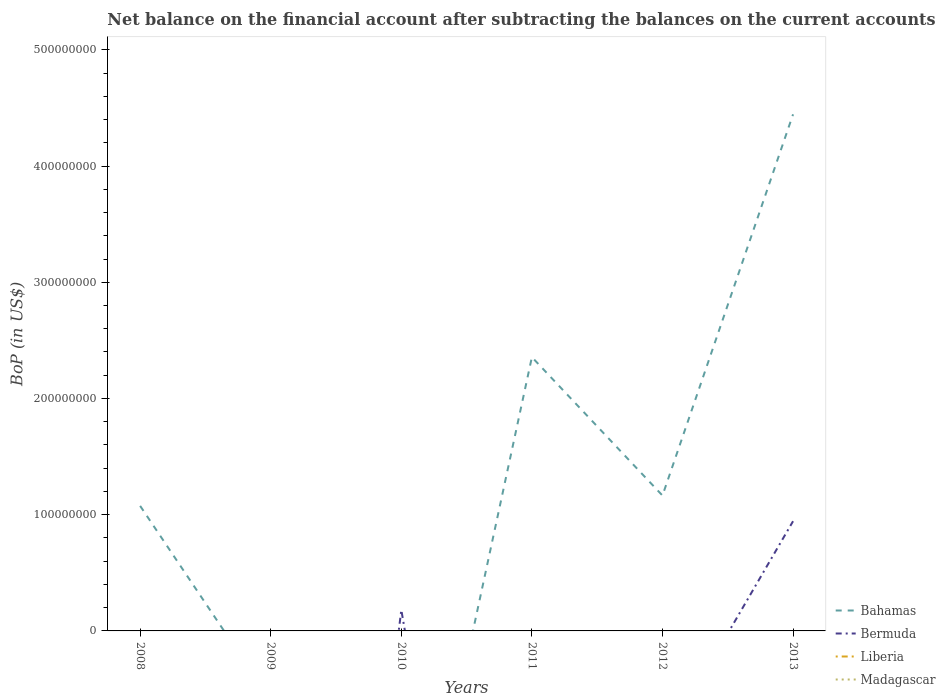Is the number of lines equal to the number of legend labels?
Make the answer very short. No. What is the total Balance of Payments in Bahamas in the graph?
Ensure brevity in your answer.  1.19e+08. What is the difference between the highest and the second highest Balance of Payments in Bahamas?
Keep it short and to the point. 4.44e+08. What is the difference between two consecutive major ticks on the Y-axis?
Provide a succinct answer. 1.00e+08. Are the values on the major ticks of Y-axis written in scientific E-notation?
Offer a terse response. No. Does the graph contain grids?
Keep it short and to the point. No. How many legend labels are there?
Offer a terse response. 4. What is the title of the graph?
Offer a terse response. Net balance on the financial account after subtracting the balances on the current accounts. Does "Belize" appear as one of the legend labels in the graph?
Make the answer very short. No. What is the label or title of the X-axis?
Offer a very short reply. Years. What is the label or title of the Y-axis?
Keep it short and to the point. BoP (in US$). What is the BoP (in US$) of Bahamas in 2008?
Offer a very short reply. 1.08e+08. What is the BoP (in US$) in Bermuda in 2008?
Your answer should be compact. 0. What is the BoP (in US$) of Liberia in 2008?
Make the answer very short. 0. What is the BoP (in US$) in Madagascar in 2008?
Provide a succinct answer. 0. What is the BoP (in US$) in Bahamas in 2009?
Provide a succinct answer. 0. What is the BoP (in US$) of Bermuda in 2009?
Offer a very short reply. 0. What is the BoP (in US$) in Liberia in 2009?
Your answer should be very brief. 0. What is the BoP (in US$) in Madagascar in 2009?
Ensure brevity in your answer.  0. What is the BoP (in US$) in Bermuda in 2010?
Keep it short and to the point. 1.80e+07. What is the BoP (in US$) of Liberia in 2010?
Give a very brief answer. 0. What is the BoP (in US$) of Madagascar in 2010?
Offer a terse response. 0. What is the BoP (in US$) of Bahamas in 2011?
Keep it short and to the point. 2.36e+08. What is the BoP (in US$) in Bermuda in 2011?
Provide a succinct answer. 0. What is the BoP (in US$) of Madagascar in 2011?
Provide a succinct answer. 0. What is the BoP (in US$) of Bahamas in 2012?
Your answer should be very brief. 1.16e+08. What is the BoP (in US$) in Bahamas in 2013?
Give a very brief answer. 4.44e+08. What is the BoP (in US$) in Bermuda in 2013?
Your answer should be compact. 9.44e+07. What is the BoP (in US$) of Liberia in 2013?
Ensure brevity in your answer.  0. Across all years, what is the maximum BoP (in US$) in Bahamas?
Ensure brevity in your answer.  4.44e+08. Across all years, what is the maximum BoP (in US$) of Bermuda?
Offer a very short reply. 9.44e+07. Across all years, what is the minimum BoP (in US$) of Bahamas?
Your response must be concise. 0. Across all years, what is the minimum BoP (in US$) of Bermuda?
Give a very brief answer. 0. What is the total BoP (in US$) of Bahamas in the graph?
Ensure brevity in your answer.  9.04e+08. What is the total BoP (in US$) in Bermuda in the graph?
Your answer should be compact. 1.12e+08. What is the total BoP (in US$) of Liberia in the graph?
Provide a succinct answer. 0. What is the total BoP (in US$) of Madagascar in the graph?
Give a very brief answer. 0. What is the difference between the BoP (in US$) of Bahamas in 2008 and that in 2011?
Give a very brief answer. -1.28e+08. What is the difference between the BoP (in US$) of Bahamas in 2008 and that in 2012?
Keep it short and to the point. -8.90e+06. What is the difference between the BoP (in US$) in Bahamas in 2008 and that in 2013?
Ensure brevity in your answer.  -3.37e+08. What is the difference between the BoP (in US$) in Bermuda in 2010 and that in 2013?
Your answer should be very brief. -7.64e+07. What is the difference between the BoP (in US$) of Bahamas in 2011 and that in 2012?
Your answer should be compact. 1.19e+08. What is the difference between the BoP (in US$) of Bahamas in 2011 and that in 2013?
Ensure brevity in your answer.  -2.09e+08. What is the difference between the BoP (in US$) of Bahamas in 2012 and that in 2013?
Ensure brevity in your answer.  -3.28e+08. What is the difference between the BoP (in US$) in Bahamas in 2008 and the BoP (in US$) in Bermuda in 2010?
Your response must be concise. 8.96e+07. What is the difference between the BoP (in US$) of Bahamas in 2008 and the BoP (in US$) of Bermuda in 2013?
Provide a succinct answer. 1.32e+07. What is the difference between the BoP (in US$) in Bahamas in 2011 and the BoP (in US$) in Bermuda in 2013?
Provide a short and direct response. 1.41e+08. What is the difference between the BoP (in US$) of Bahamas in 2012 and the BoP (in US$) of Bermuda in 2013?
Your answer should be very brief. 2.21e+07. What is the average BoP (in US$) in Bahamas per year?
Offer a terse response. 1.51e+08. What is the average BoP (in US$) of Bermuda per year?
Your response must be concise. 1.87e+07. In the year 2013, what is the difference between the BoP (in US$) in Bahamas and BoP (in US$) in Bermuda?
Make the answer very short. 3.50e+08. What is the ratio of the BoP (in US$) of Bahamas in 2008 to that in 2011?
Your response must be concise. 0.46. What is the ratio of the BoP (in US$) of Bahamas in 2008 to that in 2012?
Keep it short and to the point. 0.92. What is the ratio of the BoP (in US$) in Bahamas in 2008 to that in 2013?
Ensure brevity in your answer.  0.24. What is the ratio of the BoP (in US$) in Bermuda in 2010 to that in 2013?
Your answer should be very brief. 0.19. What is the ratio of the BoP (in US$) of Bahamas in 2011 to that in 2012?
Provide a succinct answer. 2.02. What is the ratio of the BoP (in US$) of Bahamas in 2011 to that in 2013?
Offer a very short reply. 0.53. What is the ratio of the BoP (in US$) of Bahamas in 2012 to that in 2013?
Your answer should be compact. 0.26. What is the difference between the highest and the second highest BoP (in US$) of Bahamas?
Your response must be concise. 2.09e+08. What is the difference between the highest and the lowest BoP (in US$) of Bahamas?
Provide a short and direct response. 4.44e+08. What is the difference between the highest and the lowest BoP (in US$) of Bermuda?
Offer a very short reply. 9.44e+07. 